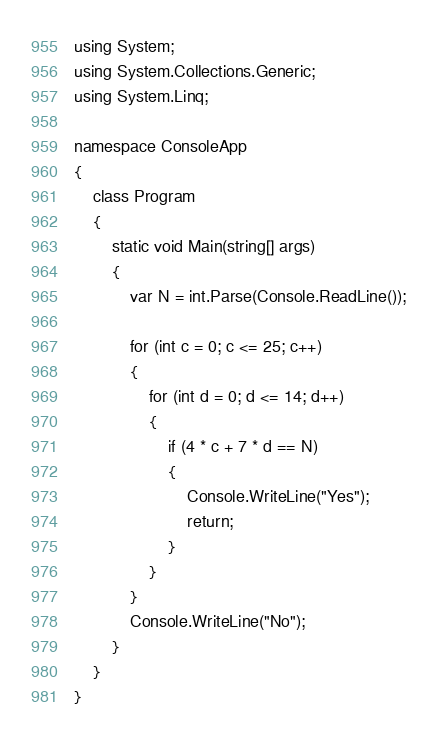Convert code to text. <code><loc_0><loc_0><loc_500><loc_500><_C#_>using System;
using System.Collections.Generic;
using System.Linq;

namespace ConsoleApp
{
    class Program
    {
        static void Main(string[] args)
        {
            var N = int.Parse(Console.ReadLine());

            for (int c = 0; c <= 25; c++)
            {
                for (int d = 0; d <= 14; d++)
                {
                    if (4 * c + 7 * d == N)
                    {
                        Console.WriteLine("Yes");
                        return;
                    }
                }
            }
            Console.WriteLine("No");
        }
    }
}</code> 